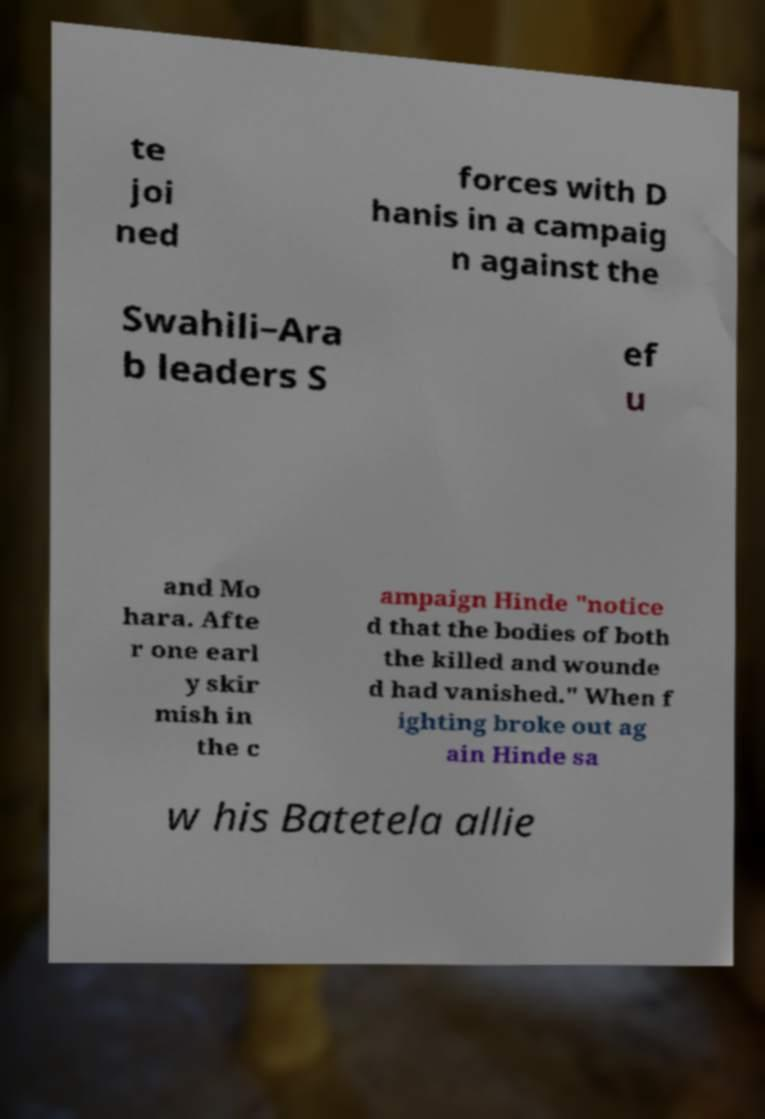Can you accurately transcribe the text from the provided image for me? te joi ned forces with D hanis in a campaig n against the Swahili–Ara b leaders S ef u and Mo hara. Afte r one earl y skir mish in the c ampaign Hinde "notice d that the bodies of both the killed and wounde d had vanished." When f ighting broke out ag ain Hinde sa w his Batetela allie 